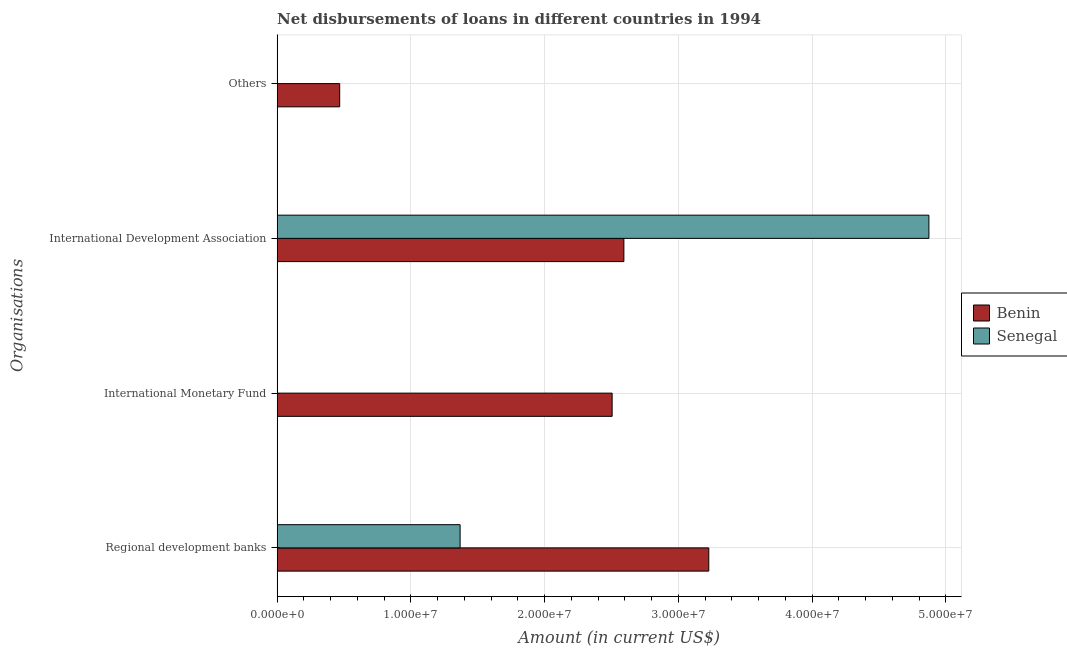How many different coloured bars are there?
Offer a very short reply. 2. Are the number of bars per tick equal to the number of legend labels?
Offer a very short reply. No. How many bars are there on the 1st tick from the top?
Offer a terse response. 1. What is the label of the 3rd group of bars from the top?
Ensure brevity in your answer.  International Monetary Fund. What is the amount of loan disimbursed by international development association in Benin?
Provide a short and direct response. 2.59e+07. Across all countries, what is the maximum amount of loan disimbursed by international monetary fund?
Provide a succinct answer. 2.51e+07. In which country was the amount of loan disimbursed by regional development banks maximum?
Provide a succinct answer. Benin. What is the total amount of loan disimbursed by other organisations in the graph?
Ensure brevity in your answer.  4.68e+06. What is the difference between the amount of loan disimbursed by international development association in Benin and that in Senegal?
Give a very brief answer. -2.28e+07. What is the difference between the amount of loan disimbursed by international development association in Benin and the amount of loan disimbursed by international monetary fund in Senegal?
Provide a succinct answer. 2.59e+07. What is the average amount of loan disimbursed by regional development banks per country?
Your answer should be compact. 2.30e+07. What is the difference between the amount of loan disimbursed by international monetary fund and amount of loan disimbursed by regional development banks in Benin?
Give a very brief answer. -7.23e+06. What is the ratio of the amount of loan disimbursed by regional development banks in Benin to that in Senegal?
Your response must be concise. 2.36. What is the difference between the highest and the second highest amount of loan disimbursed by international development association?
Provide a succinct answer. 2.28e+07. What is the difference between the highest and the lowest amount of loan disimbursed by international development association?
Your answer should be compact. 2.28e+07. Is the sum of the amount of loan disimbursed by regional development banks in Senegal and Benin greater than the maximum amount of loan disimbursed by international development association across all countries?
Provide a short and direct response. No. How many bars are there?
Give a very brief answer. 6. Are all the bars in the graph horizontal?
Provide a short and direct response. Yes. How many countries are there in the graph?
Your answer should be very brief. 2. What is the difference between two consecutive major ticks on the X-axis?
Your response must be concise. 1.00e+07. Are the values on the major ticks of X-axis written in scientific E-notation?
Make the answer very short. Yes. Where does the legend appear in the graph?
Make the answer very short. Center right. How many legend labels are there?
Ensure brevity in your answer.  2. What is the title of the graph?
Offer a very short reply. Net disbursements of loans in different countries in 1994. Does "Guyana" appear as one of the legend labels in the graph?
Your response must be concise. No. What is the label or title of the Y-axis?
Provide a short and direct response. Organisations. What is the Amount (in current US$) of Benin in Regional development banks?
Provide a succinct answer. 3.23e+07. What is the Amount (in current US$) in Senegal in Regional development banks?
Offer a terse response. 1.37e+07. What is the Amount (in current US$) in Benin in International Monetary Fund?
Provide a short and direct response. 2.51e+07. What is the Amount (in current US$) of Senegal in International Monetary Fund?
Ensure brevity in your answer.  0. What is the Amount (in current US$) of Benin in International Development Association?
Your answer should be very brief. 2.59e+07. What is the Amount (in current US$) in Senegal in International Development Association?
Your answer should be compact. 4.87e+07. What is the Amount (in current US$) in Benin in Others?
Make the answer very short. 4.68e+06. What is the Amount (in current US$) in Senegal in Others?
Your answer should be compact. 0. Across all Organisations, what is the maximum Amount (in current US$) of Benin?
Provide a short and direct response. 3.23e+07. Across all Organisations, what is the maximum Amount (in current US$) of Senegal?
Provide a short and direct response. 4.87e+07. Across all Organisations, what is the minimum Amount (in current US$) of Benin?
Give a very brief answer. 4.68e+06. What is the total Amount (in current US$) of Benin in the graph?
Your answer should be very brief. 8.79e+07. What is the total Amount (in current US$) in Senegal in the graph?
Offer a terse response. 6.24e+07. What is the difference between the Amount (in current US$) in Benin in Regional development banks and that in International Monetary Fund?
Provide a succinct answer. 7.23e+06. What is the difference between the Amount (in current US$) of Benin in Regional development banks and that in International Development Association?
Your answer should be compact. 6.35e+06. What is the difference between the Amount (in current US$) of Senegal in Regional development banks and that in International Development Association?
Keep it short and to the point. -3.51e+07. What is the difference between the Amount (in current US$) of Benin in Regional development banks and that in Others?
Your response must be concise. 2.76e+07. What is the difference between the Amount (in current US$) in Benin in International Monetary Fund and that in International Development Association?
Make the answer very short. -8.78e+05. What is the difference between the Amount (in current US$) in Benin in International Monetary Fund and that in Others?
Offer a terse response. 2.04e+07. What is the difference between the Amount (in current US$) of Benin in International Development Association and that in Others?
Your answer should be compact. 2.13e+07. What is the difference between the Amount (in current US$) of Benin in Regional development banks and the Amount (in current US$) of Senegal in International Development Association?
Ensure brevity in your answer.  -1.65e+07. What is the difference between the Amount (in current US$) of Benin in International Monetary Fund and the Amount (in current US$) of Senegal in International Development Association?
Make the answer very short. -2.37e+07. What is the average Amount (in current US$) of Benin per Organisations?
Provide a short and direct response. 2.20e+07. What is the average Amount (in current US$) in Senegal per Organisations?
Offer a terse response. 1.56e+07. What is the difference between the Amount (in current US$) in Benin and Amount (in current US$) in Senegal in Regional development banks?
Your answer should be very brief. 1.86e+07. What is the difference between the Amount (in current US$) of Benin and Amount (in current US$) of Senegal in International Development Association?
Give a very brief answer. -2.28e+07. What is the ratio of the Amount (in current US$) of Benin in Regional development banks to that in International Monetary Fund?
Your answer should be very brief. 1.29. What is the ratio of the Amount (in current US$) in Benin in Regional development banks to that in International Development Association?
Your answer should be compact. 1.24. What is the ratio of the Amount (in current US$) in Senegal in Regional development banks to that in International Development Association?
Your answer should be compact. 0.28. What is the ratio of the Amount (in current US$) of Benin in Regional development banks to that in Others?
Offer a very short reply. 6.9. What is the ratio of the Amount (in current US$) of Benin in International Monetary Fund to that in International Development Association?
Offer a very short reply. 0.97. What is the ratio of the Amount (in current US$) in Benin in International Monetary Fund to that in Others?
Provide a succinct answer. 5.35. What is the ratio of the Amount (in current US$) of Benin in International Development Association to that in Others?
Provide a succinct answer. 5.54. What is the difference between the highest and the second highest Amount (in current US$) in Benin?
Provide a succinct answer. 6.35e+06. What is the difference between the highest and the lowest Amount (in current US$) in Benin?
Offer a terse response. 2.76e+07. What is the difference between the highest and the lowest Amount (in current US$) in Senegal?
Provide a short and direct response. 4.87e+07. 